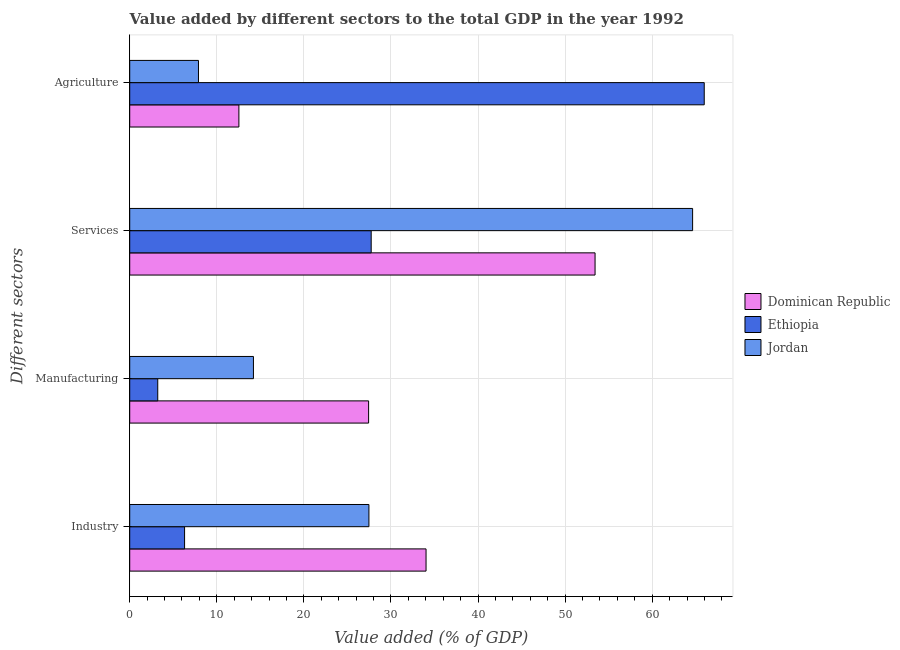How many groups of bars are there?
Keep it short and to the point. 4. Are the number of bars per tick equal to the number of legend labels?
Your response must be concise. Yes. How many bars are there on the 3rd tick from the bottom?
Offer a terse response. 3. What is the label of the 1st group of bars from the top?
Ensure brevity in your answer.  Agriculture. What is the value added by industrial sector in Dominican Republic?
Your response must be concise. 34.03. Across all countries, what is the maximum value added by agricultural sector?
Offer a terse response. 65.97. Across all countries, what is the minimum value added by industrial sector?
Give a very brief answer. 6.3. In which country was the value added by industrial sector maximum?
Offer a terse response. Dominican Republic. In which country was the value added by agricultural sector minimum?
Your answer should be very brief. Jordan. What is the total value added by services sector in the graph?
Your response must be concise. 145.8. What is the difference between the value added by industrial sector in Ethiopia and that in Dominican Republic?
Give a very brief answer. -27.73. What is the difference between the value added by services sector in Ethiopia and the value added by industrial sector in Jordan?
Your answer should be compact. 0.26. What is the average value added by manufacturing sector per country?
Your answer should be very brief. 14.95. What is the difference between the value added by manufacturing sector and value added by industrial sector in Jordan?
Give a very brief answer. -13.26. In how many countries, is the value added by services sector greater than 26 %?
Offer a terse response. 3. What is the ratio of the value added by services sector in Jordan to that in Ethiopia?
Ensure brevity in your answer.  2.33. Is the difference between the value added by industrial sector in Dominican Republic and Jordan greater than the difference between the value added by agricultural sector in Dominican Republic and Jordan?
Ensure brevity in your answer.  Yes. What is the difference between the highest and the second highest value added by industrial sector?
Your answer should be compact. 6.56. What is the difference between the highest and the lowest value added by agricultural sector?
Give a very brief answer. 58.08. In how many countries, is the value added by industrial sector greater than the average value added by industrial sector taken over all countries?
Give a very brief answer. 2. What does the 1st bar from the top in Agriculture represents?
Your response must be concise. Jordan. What does the 2nd bar from the bottom in Manufacturing represents?
Your response must be concise. Ethiopia. Is it the case that in every country, the sum of the value added by industrial sector and value added by manufacturing sector is greater than the value added by services sector?
Offer a terse response. No. How many bars are there?
Provide a short and direct response. 12. Are all the bars in the graph horizontal?
Keep it short and to the point. Yes. How many countries are there in the graph?
Ensure brevity in your answer.  3. What is the difference between two consecutive major ticks on the X-axis?
Ensure brevity in your answer.  10. Are the values on the major ticks of X-axis written in scientific E-notation?
Your response must be concise. No. Does the graph contain grids?
Offer a very short reply. Yes. How many legend labels are there?
Your answer should be compact. 3. How are the legend labels stacked?
Offer a very short reply. Vertical. What is the title of the graph?
Offer a very short reply. Value added by different sectors to the total GDP in the year 1992. Does "Macedonia" appear as one of the legend labels in the graph?
Provide a short and direct response. No. What is the label or title of the X-axis?
Provide a short and direct response. Value added (% of GDP). What is the label or title of the Y-axis?
Your response must be concise. Different sectors. What is the Value added (% of GDP) in Dominican Republic in Industry?
Ensure brevity in your answer.  34.03. What is the Value added (% of GDP) of Ethiopia in Industry?
Make the answer very short. 6.3. What is the Value added (% of GDP) of Jordan in Industry?
Offer a terse response. 27.47. What is the Value added (% of GDP) in Dominican Republic in Manufacturing?
Offer a very short reply. 27.43. What is the Value added (% of GDP) of Ethiopia in Manufacturing?
Ensure brevity in your answer.  3.22. What is the Value added (% of GDP) of Jordan in Manufacturing?
Keep it short and to the point. 14.21. What is the Value added (% of GDP) of Dominican Republic in Services?
Give a very brief answer. 53.44. What is the Value added (% of GDP) of Ethiopia in Services?
Offer a terse response. 27.73. What is the Value added (% of GDP) of Jordan in Services?
Offer a terse response. 64.64. What is the Value added (% of GDP) in Dominican Republic in Agriculture?
Your answer should be compact. 12.54. What is the Value added (% of GDP) in Ethiopia in Agriculture?
Make the answer very short. 65.97. What is the Value added (% of GDP) of Jordan in Agriculture?
Give a very brief answer. 7.89. Across all Different sectors, what is the maximum Value added (% of GDP) in Dominican Republic?
Keep it short and to the point. 53.44. Across all Different sectors, what is the maximum Value added (% of GDP) of Ethiopia?
Provide a short and direct response. 65.97. Across all Different sectors, what is the maximum Value added (% of GDP) of Jordan?
Your answer should be compact. 64.64. Across all Different sectors, what is the minimum Value added (% of GDP) in Dominican Republic?
Provide a succinct answer. 12.54. Across all Different sectors, what is the minimum Value added (% of GDP) in Ethiopia?
Make the answer very short. 3.22. Across all Different sectors, what is the minimum Value added (% of GDP) of Jordan?
Provide a succinct answer. 7.89. What is the total Value added (% of GDP) in Dominican Republic in the graph?
Give a very brief answer. 127.43. What is the total Value added (% of GDP) in Ethiopia in the graph?
Keep it short and to the point. 103.22. What is the total Value added (% of GDP) of Jordan in the graph?
Ensure brevity in your answer.  114.21. What is the difference between the Value added (% of GDP) of Dominican Republic in Industry and that in Manufacturing?
Offer a very short reply. 6.6. What is the difference between the Value added (% of GDP) in Ethiopia in Industry and that in Manufacturing?
Ensure brevity in your answer.  3.08. What is the difference between the Value added (% of GDP) in Jordan in Industry and that in Manufacturing?
Ensure brevity in your answer.  13.26. What is the difference between the Value added (% of GDP) of Dominican Republic in Industry and that in Services?
Keep it short and to the point. -19.41. What is the difference between the Value added (% of GDP) of Ethiopia in Industry and that in Services?
Your response must be concise. -21.43. What is the difference between the Value added (% of GDP) in Jordan in Industry and that in Services?
Give a very brief answer. -37.17. What is the difference between the Value added (% of GDP) of Dominican Republic in Industry and that in Agriculture?
Keep it short and to the point. 21.49. What is the difference between the Value added (% of GDP) of Ethiopia in Industry and that in Agriculture?
Your answer should be compact. -59.67. What is the difference between the Value added (% of GDP) of Jordan in Industry and that in Agriculture?
Make the answer very short. 19.57. What is the difference between the Value added (% of GDP) in Dominican Republic in Manufacturing and that in Services?
Make the answer very short. -26. What is the difference between the Value added (% of GDP) in Ethiopia in Manufacturing and that in Services?
Keep it short and to the point. -24.51. What is the difference between the Value added (% of GDP) in Jordan in Manufacturing and that in Services?
Make the answer very short. -50.43. What is the difference between the Value added (% of GDP) in Dominican Republic in Manufacturing and that in Agriculture?
Your answer should be compact. 14.9. What is the difference between the Value added (% of GDP) of Ethiopia in Manufacturing and that in Agriculture?
Offer a terse response. -62.76. What is the difference between the Value added (% of GDP) in Jordan in Manufacturing and that in Agriculture?
Offer a terse response. 6.31. What is the difference between the Value added (% of GDP) in Dominican Republic in Services and that in Agriculture?
Offer a terse response. 40.9. What is the difference between the Value added (% of GDP) in Ethiopia in Services and that in Agriculture?
Your response must be concise. -38.24. What is the difference between the Value added (% of GDP) of Jordan in Services and that in Agriculture?
Your response must be concise. 56.74. What is the difference between the Value added (% of GDP) of Dominican Republic in Industry and the Value added (% of GDP) of Ethiopia in Manufacturing?
Provide a short and direct response. 30.81. What is the difference between the Value added (% of GDP) in Dominican Republic in Industry and the Value added (% of GDP) in Jordan in Manufacturing?
Provide a succinct answer. 19.82. What is the difference between the Value added (% of GDP) in Ethiopia in Industry and the Value added (% of GDP) in Jordan in Manufacturing?
Make the answer very short. -7.91. What is the difference between the Value added (% of GDP) in Dominican Republic in Industry and the Value added (% of GDP) in Ethiopia in Services?
Your response must be concise. 6.3. What is the difference between the Value added (% of GDP) of Dominican Republic in Industry and the Value added (% of GDP) of Jordan in Services?
Make the answer very short. -30.61. What is the difference between the Value added (% of GDP) of Ethiopia in Industry and the Value added (% of GDP) of Jordan in Services?
Give a very brief answer. -58.34. What is the difference between the Value added (% of GDP) in Dominican Republic in Industry and the Value added (% of GDP) in Ethiopia in Agriculture?
Keep it short and to the point. -31.94. What is the difference between the Value added (% of GDP) of Dominican Republic in Industry and the Value added (% of GDP) of Jordan in Agriculture?
Provide a succinct answer. 26.13. What is the difference between the Value added (% of GDP) of Ethiopia in Industry and the Value added (% of GDP) of Jordan in Agriculture?
Your response must be concise. -1.6. What is the difference between the Value added (% of GDP) of Dominican Republic in Manufacturing and the Value added (% of GDP) of Ethiopia in Services?
Your answer should be compact. -0.3. What is the difference between the Value added (% of GDP) of Dominican Republic in Manufacturing and the Value added (% of GDP) of Jordan in Services?
Give a very brief answer. -37.21. What is the difference between the Value added (% of GDP) of Ethiopia in Manufacturing and the Value added (% of GDP) of Jordan in Services?
Offer a very short reply. -61.42. What is the difference between the Value added (% of GDP) of Dominican Republic in Manufacturing and the Value added (% of GDP) of Ethiopia in Agriculture?
Your answer should be very brief. -38.54. What is the difference between the Value added (% of GDP) in Dominican Republic in Manufacturing and the Value added (% of GDP) in Jordan in Agriculture?
Your answer should be compact. 19.54. What is the difference between the Value added (% of GDP) of Ethiopia in Manufacturing and the Value added (% of GDP) of Jordan in Agriculture?
Ensure brevity in your answer.  -4.68. What is the difference between the Value added (% of GDP) in Dominican Republic in Services and the Value added (% of GDP) in Ethiopia in Agriculture?
Make the answer very short. -12.54. What is the difference between the Value added (% of GDP) in Dominican Republic in Services and the Value added (% of GDP) in Jordan in Agriculture?
Your response must be concise. 45.54. What is the difference between the Value added (% of GDP) of Ethiopia in Services and the Value added (% of GDP) of Jordan in Agriculture?
Ensure brevity in your answer.  19.83. What is the average Value added (% of GDP) of Dominican Republic per Different sectors?
Keep it short and to the point. 31.86. What is the average Value added (% of GDP) in Ethiopia per Different sectors?
Your response must be concise. 25.8. What is the average Value added (% of GDP) in Jordan per Different sectors?
Keep it short and to the point. 28.55. What is the difference between the Value added (% of GDP) in Dominican Republic and Value added (% of GDP) in Ethiopia in Industry?
Offer a very short reply. 27.73. What is the difference between the Value added (% of GDP) in Dominican Republic and Value added (% of GDP) in Jordan in Industry?
Offer a very short reply. 6.56. What is the difference between the Value added (% of GDP) of Ethiopia and Value added (% of GDP) of Jordan in Industry?
Provide a short and direct response. -21.17. What is the difference between the Value added (% of GDP) in Dominican Republic and Value added (% of GDP) in Ethiopia in Manufacturing?
Provide a short and direct response. 24.21. What is the difference between the Value added (% of GDP) in Dominican Republic and Value added (% of GDP) in Jordan in Manufacturing?
Your response must be concise. 13.22. What is the difference between the Value added (% of GDP) in Ethiopia and Value added (% of GDP) in Jordan in Manufacturing?
Keep it short and to the point. -10.99. What is the difference between the Value added (% of GDP) in Dominican Republic and Value added (% of GDP) in Ethiopia in Services?
Offer a very short reply. 25.71. What is the difference between the Value added (% of GDP) of Dominican Republic and Value added (% of GDP) of Jordan in Services?
Ensure brevity in your answer.  -11.2. What is the difference between the Value added (% of GDP) in Ethiopia and Value added (% of GDP) in Jordan in Services?
Keep it short and to the point. -36.91. What is the difference between the Value added (% of GDP) in Dominican Republic and Value added (% of GDP) in Ethiopia in Agriculture?
Make the answer very short. -53.44. What is the difference between the Value added (% of GDP) in Dominican Republic and Value added (% of GDP) in Jordan in Agriculture?
Ensure brevity in your answer.  4.64. What is the difference between the Value added (% of GDP) of Ethiopia and Value added (% of GDP) of Jordan in Agriculture?
Give a very brief answer. 58.08. What is the ratio of the Value added (% of GDP) of Dominican Republic in Industry to that in Manufacturing?
Your response must be concise. 1.24. What is the ratio of the Value added (% of GDP) in Ethiopia in Industry to that in Manufacturing?
Ensure brevity in your answer.  1.96. What is the ratio of the Value added (% of GDP) of Jordan in Industry to that in Manufacturing?
Your answer should be very brief. 1.93. What is the ratio of the Value added (% of GDP) of Dominican Republic in Industry to that in Services?
Provide a succinct answer. 0.64. What is the ratio of the Value added (% of GDP) of Ethiopia in Industry to that in Services?
Your response must be concise. 0.23. What is the ratio of the Value added (% of GDP) of Jordan in Industry to that in Services?
Provide a succinct answer. 0.42. What is the ratio of the Value added (% of GDP) of Dominican Republic in Industry to that in Agriculture?
Your answer should be very brief. 2.71. What is the ratio of the Value added (% of GDP) of Ethiopia in Industry to that in Agriculture?
Make the answer very short. 0.1. What is the ratio of the Value added (% of GDP) in Jordan in Industry to that in Agriculture?
Provide a short and direct response. 3.48. What is the ratio of the Value added (% of GDP) in Dominican Republic in Manufacturing to that in Services?
Provide a short and direct response. 0.51. What is the ratio of the Value added (% of GDP) of Ethiopia in Manufacturing to that in Services?
Your answer should be compact. 0.12. What is the ratio of the Value added (% of GDP) in Jordan in Manufacturing to that in Services?
Provide a succinct answer. 0.22. What is the ratio of the Value added (% of GDP) in Dominican Republic in Manufacturing to that in Agriculture?
Provide a short and direct response. 2.19. What is the ratio of the Value added (% of GDP) in Ethiopia in Manufacturing to that in Agriculture?
Ensure brevity in your answer.  0.05. What is the ratio of the Value added (% of GDP) of Jordan in Manufacturing to that in Agriculture?
Your answer should be very brief. 1.8. What is the ratio of the Value added (% of GDP) of Dominican Republic in Services to that in Agriculture?
Provide a succinct answer. 4.26. What is the ratio of the Value added (% of GDP) of Ethiopia in Services to that in Agriculture?
Provide a succinct answer. 0.42. What is the ratio of the Value added (% of GDP) of Jordan in Services to that in Agriculture?
Provide a short and direct response. 8.19. What is the difference between the highest and the second highest Value added (% of GDP) of Dominican Republic?
Your response must be concise. 19.41. What is the difference between the highest and the second highest Value added (% of GDP) in Ethiopia?
Provide a short and direct response. 38.24. What is the difference between the highest and the second highest Value added (% of GDP) of Jordan?
Provide a short and direct response. 37.17. What is the difference between the highest and the lowest Value added (% of GDP) of Dominican Republic?
Offer a terse response. 40.9. What is the difference between the highest and the lowest Value added (% of GDP) in Ethiopia?
Offer a very short reply. 62.76. What is the difference between the highest and the lowest Value added (% of GDP) in Jordan?
Your answer should be very brief. 56.74. 